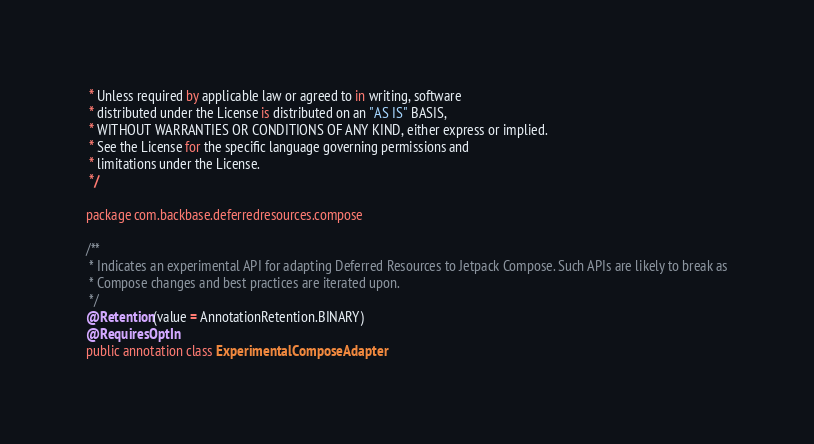Convert code to text. <code><loc_0><loc_0><loc_500><loc_500><_Kotlin_> * Unless required by applicable law or agreed to in writing, software
 * distributed under the License is distributed on an "AS IS" BASIS,
 * WITHOUT WARRANTIES OR CONDITIONS OF ANY KIND, either express or implied.
 * See the License for the specific language governing permissions and
 * limitations under the License.
 */

package com.backbase.deferredresources.compose

/**
 * Indicates an experimental API for adapting Deferred Resources to Jetpack Compose. Such APIs are likely to break as
 * Compose changes and best practices are iterated upon.
 */
@Retention(value = AnnotationRetention.BINARY)
@RequiresOptIn
public annotation class ExperimentalComposeAdapter
</code> 